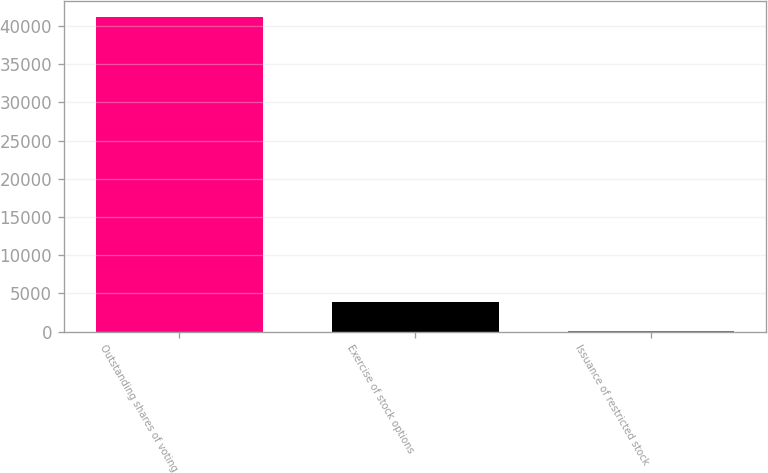Convert chart. <chart><loc_0><loc_0><loc_500><loc_500><bar_chart><fcel>Outstanding shares of voting<fcel>Exercise of stock options<fcel>Issuance of restricted stock<nl><fcel>41173.3<fcel>3832.3<fcel>66<nl></chart> 